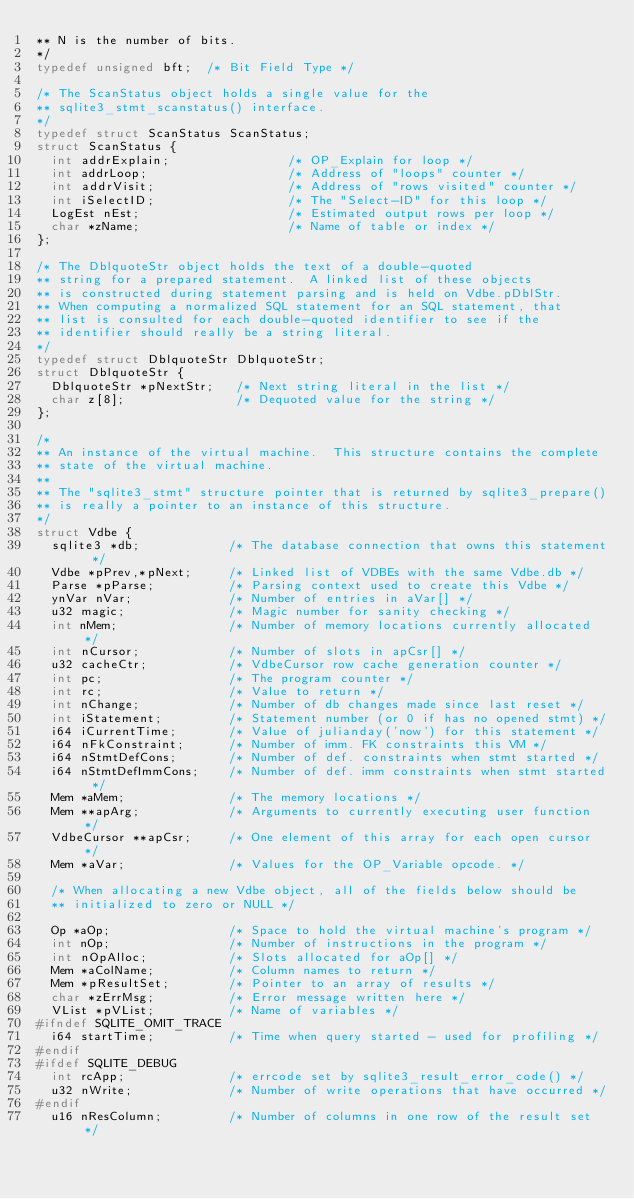Convert code to text. <code><loc_0><loc_0><loc_500><loc_500><_C_>** N is the number of bits.
*/
typedef unsigned bft;  /* Bit Field Type */

/* The ScanStatus object holds a single value for the
** sqlite3_stmt_scanstatus() interface.
*/
typedef struct ScanStatus ScanStatus;
struct ScanStatus {
  int addrExplain;                /* OP_Explain for loop */
  int addrLoop;                   /* Address of "loops" counter */
  int addrVisit;                  /* Address of "rows visited" counter */
  int iSelectID;                  /* The "Select-ID" for this loop */
  LogEst nEst;                    /* Estimated output rows per loop */
  char *zName;                    /* Name of table or index */
};

/* The DblquoteStr object holds the text of a double-quoted
** string for a prepared statement.  A linked list of these objects
** is constructed during statement parsing and is held on Vdbe.pDblStr.
** When computing a normalized SQL statement for an SQL statement, that
** list is consulted for each double-quoted identifier to see if the
** identifier should really be a string literal.
*/
typedef struct DblquoteStr DblquoteStr;
struct DblquoteStr {
  DblquoteStr *pNextStr;   /* Next string literal in the list */
  char z[8];               /* Dequoted value for the string */
};

/*
** An instance of the virtual machine.  This structure contains the complete
** state of the virtual machine.
**
** The "sqlite3_stmt" structure pointer that is returned by sqlite3_prepare()
** is really a pointer to an instance of this structure.
*/
struct Vdbe {
  sqlite3 *db;            /* The database connection that owns this statement */
  Vdbe *pPrev,*pNext;     /* Linked list of VDBEs with the same Vdbe.db */
  Parse *pParse;          /* Parsing context used to create this Vdbe */
  ynVar nVar;             /* Number of entries in aVar[] */
  u32 magic;              /* Magic number for sanity checking */
  int nMem;               /* Number of memory locations currently allocated */
  int nCursor;            /* Number of slots in apCsr[] */
  u32 cacheCtr;           /* VdbeCursor row cache generation counter */
  int pc;                 /* The program counter */
  int rc;                 /* Value to return */
  int nChange;            /* Number of db changes made since last reset */
  int iStatement;         /* Statement number (or 0 if has no opened stmt) */
  i64 iCurrentTime;       /* Value of julianday('now') for this statement */
  i64 nFkConstraint;      /* Number of imm. FK constraints this VM */
  i64 nStmtDefCons;       /* Number of def. constraints when stmt started */
  i64 nStmtDefImmCons;    /* Number of def. imm constraints when stmt started */
  Mem *aMem;              /* The memory locations */
  Mem **apArg;            /* Arguments to currently executing user function */
  VdbeCursor **apCsr;     /* One element of this array for each open cursor */
  Mem *aVar;              /* Values for the OP_Variable opcode. */

  /* When allocating a new Vdbe object, all of the fields below should be
  ** initialized to zero or NULL */

  Op *aOp;                /* Space to hold the virtual machine's program */
  int nOp;                /* Number of instructions in the program */
  int nOpAlloc;           /* Slots allocated for aOp[] */
  Mem *aColName;          /* Column names to return */
  Mem *pResultSet;        /* Pointer to an array of results */
  char *zErrMsg;          /* Error message written here */
  VList *pVList;          /* Name of variables */
#ifndef SQLITE_OMIT_TRACE
  i64 startTime;          /* Time when query started - used for profiling */
#endif
#ifdef SQLITE_DEBUG
  int rcApp;              /* errcode set by sqlite3_result_error_code() */
  u32 nWrite;             /* Number of write operations that have occurred */
#endif
  u16 nResColumn;         /* Number of columns in one row of the result set */</code> 